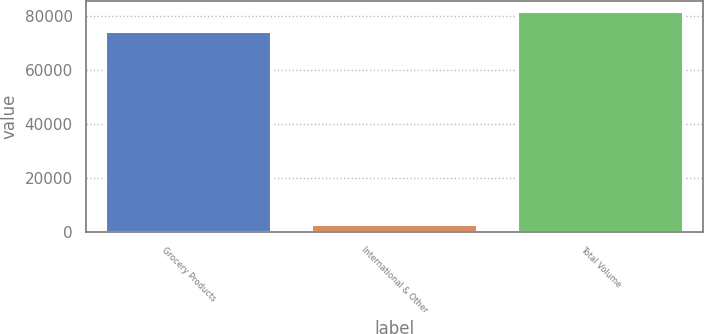Convert chart. <chart><loc_0><loc_0><loc_500><loc_500><bar_chart><fcel>Grocery Products<fcel>International & Other<fcel>Total Volume<nl><fcel>73915<fcel>2626<fcel>81306.5<nl></chart> 